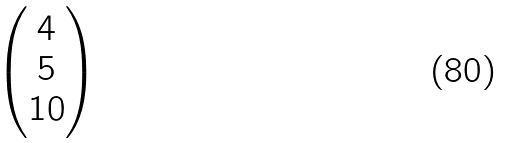Convert formula to latex. <formula><loc_0><loc_0><loc_500><loc_500>\begin{pmatrix} 4 \\ 5 \\ 1 0 \end{pmatrix}</formula> 